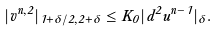Convert formula to latex. <formula><loc_0><loc_0><loc_500><loc_500>| v ^ { n , 2 } | _ { 1 + \delta / 2 , 2 + \delta } \leq K _ { 0 } | d ^ { 2 } u ^ { n - 1 } | _ { \delta } .</formula> 